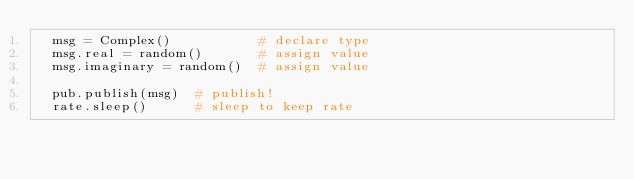<code> <loc_0><loc_0><loc_500><loc_500><_Python_>  msg = Complex()           # declare type
  msg.real = random()       # assign value
  msg.imaginary = random()  # assign value

  pub.publish(msg)  # publish!
  rate.sleep()      # sleep to keep rate</code> 